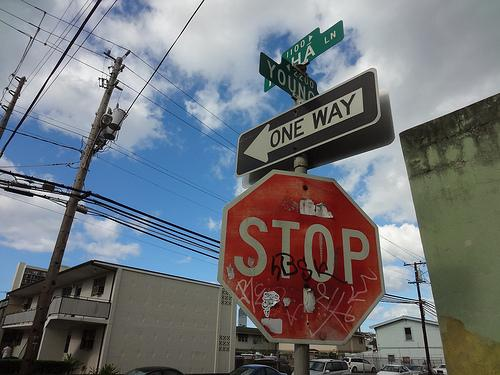Write down the street name and number on the green sign. The green sign says "2200 young." What type of sign is covering the stop sign with graffiti? A graffiti-covered stop sign. Briefly describe the atmosphere and setting of the image. A partly cloudy day with a scene outside showcasing buildings, signs, and a parking lot. What is the weather situation in the image? The sky is partly cloudy with some blue sky and dark heavy clouds. Count the number of signs in the image. There are 9 different signs in the image. Describe the sentiment or mood of the image. The mood of the image is neutral, portraying an everyday outdoor scene during the daytime. Analyze the interaction between the stop sign and the one-way sign. The graffiti-covered stop sign is beneath the black and white one-way sign pointed left, and they're both mounted on a pole. Identify the type and color of the building on the right. The building on the right is an unknown cement building, and the top of it is black. What unusual feature is present on the balcony located on the second floor? The balcony has a completely closed-in fencing. Mention the objects present in the parking lot. A parking lot has several cars and a white van parked on the side of the road. 